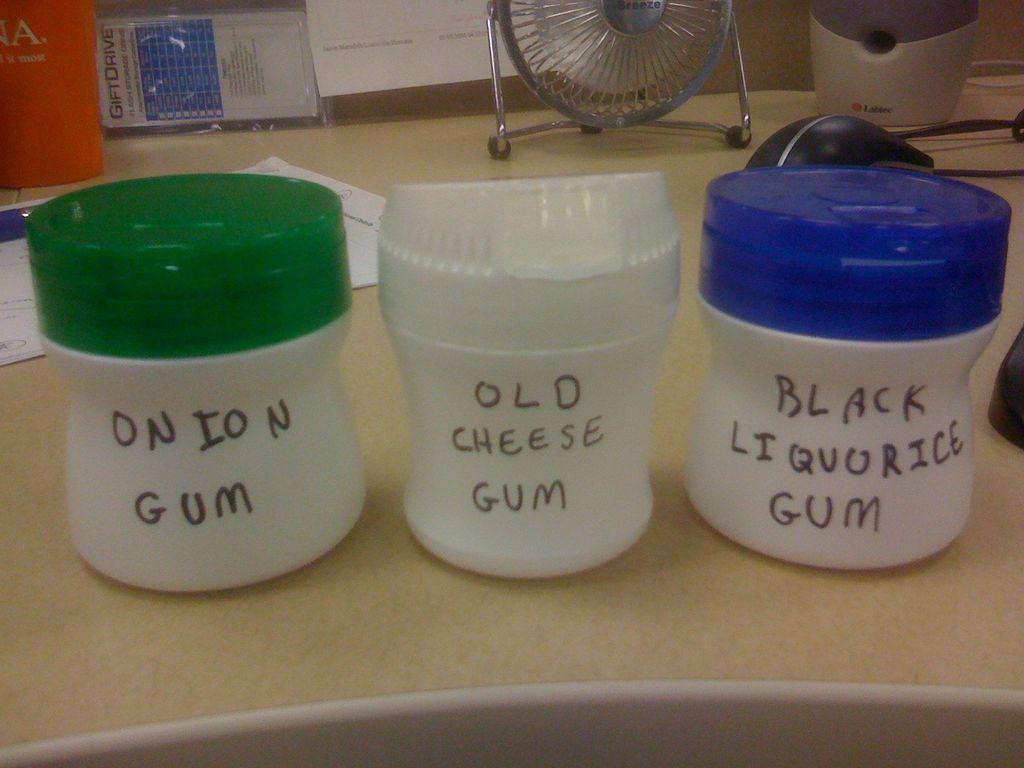What is written on the container with the blue lid?
Keep it short and to the point. Black liquorice gum. 